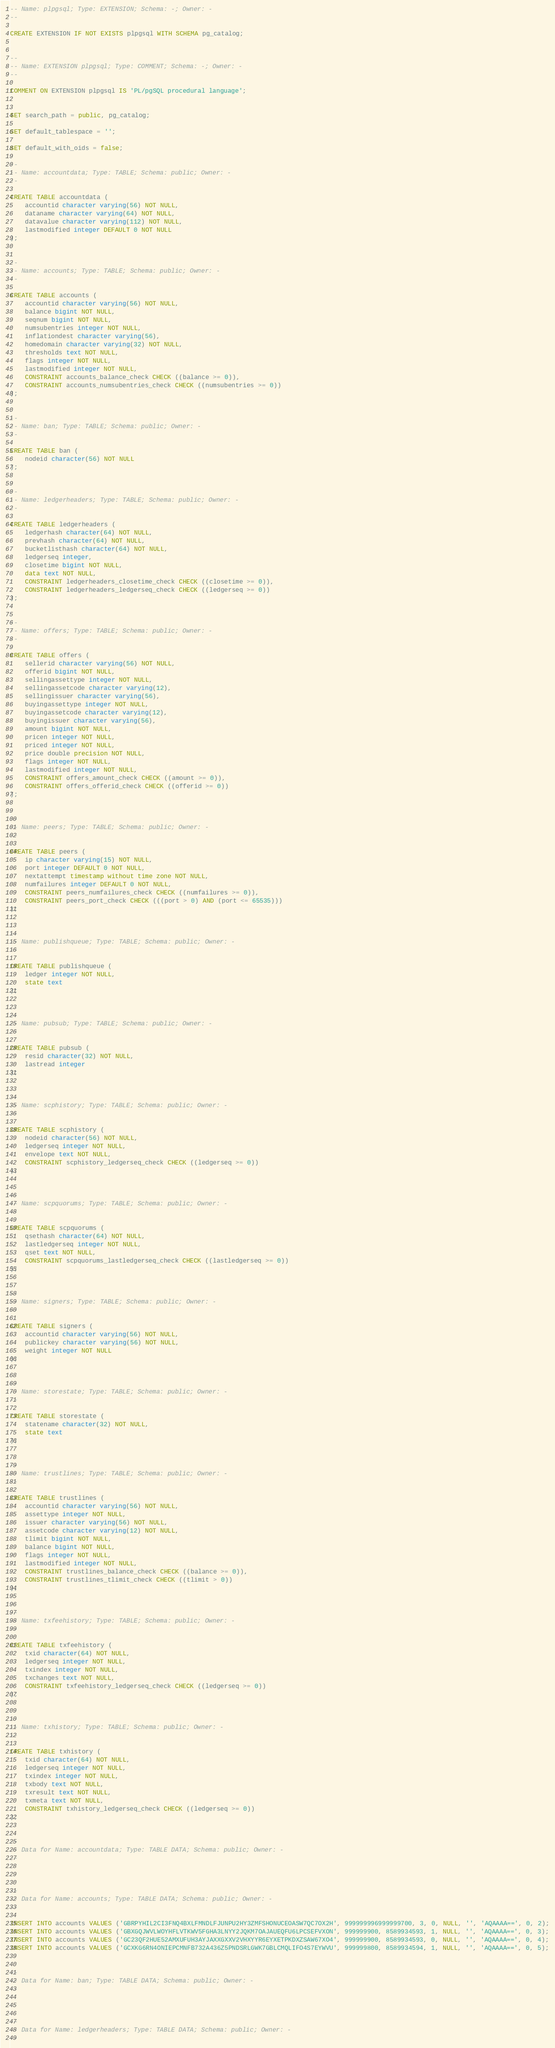Convert code to text. <code><loc_0><loc_0><loc_500><loc_500><_SQL_>-- Name: plpgsql; Type: EXTENSION; Schema: -; Owner: -
--

CREATE EXTENSION IF NOT EXISTS plpgsql WITH SCHEMA pg_catalog;


--
-- Name: EXTENSION plpgsql; Type: COMMENT; Schema: -; Owner: -
--

COMMENT ON EXTENSION plpgsql IS 'PL/pgSQL procedural language';


SET search_path = public, pg_catalog;

SET default_tablespace = '';

SET default_with_oids = false;

--
-- Name: accountdata; Type: TABLE; Schema: public; Owner: -
--

CREATE TABLE accountdata (
    accountid character varying(56) NOT NULL,
    dataname character varying(64) NOT NULL,
    datavalue character varying(112) NOT NULL,
    lastmodified integer DEFAULT 0 NOT NULL
);


--
-- Name: accounts; Type: TABLE; Schema: public; Owner: -
--

CREATE TABLE accounts (
    accountid character varying(56) NOT NULL,
    balance bigint NOT NULL,
    seqnum bigint NOT NULL,
    numsubentries integer NOT NULL,
    inflationdest character varying(56),
    homedomain character varying(32) NOT NULL,
    thresholds text NOT NULL,
    flags integer NOT NULL,
    lastmodified integer NOT NULL,
    CONSTRAINT accounts_balance_check CHECK ((balance >= 0)),
    CONSTRAINT accounts_numsubentries_check CHECK ((numsubentries >= 0))
);


--
-- Name: ban; Type: TABLE; Schema: public; Owner: -
--

CREATE TABLE ban (
    nodeid character(56) NOT NULL
);


--
-- Name: ledgerheaders; Type: TABLE; Schema: public; Owner: -
--

CREATE TABLE ledgerheaders (
    ledgerhash character(64) NOT NULL,
    prevhash character(64) NOT NULL,
    bucketlisthash character(64) NOT NULL,
    ledgerseq integer,
    closetime bigint NOT NULL,
    data text NOT NULL,
    CONSTRAINT ledgerheaders_closetime_check CHECK ((closetime >= 0)),
    CONSTRAINT ledgerheaders_ledgerseq_check CHECK ((ledgerseq >= 0))
);


--
-- Name: offers; Type: TABLE; Schema: public; Owner: -
--

CREATE TABLE offers (
    sellerid character varying(56) NOT NULL,
    offerid bigint NOT NULL,
    sellingassettype integer NOT NULL,
    sellingassetcode character varying(12),
    sellingissuer character varying(56),
    buyingassettype integer NOT NULL,
    buyingassetcode character varying(12),
    buyingissuer character varying(56),
    amount bigint NOT NULL,
    pricen integer NOT NULL,
    priced integer NOT NULL,
    price double precision NOT NULL,
    flags integer NOT NULL,
    lastmodified integer NOT NULL,
    CONSTRAINT offers_amount_check CHECK ((amount >= 0)),
    CONSTRAINT offers_offerid_check CHECK ((offerid >= 0))
);


--
-- Name: peers; Type: TABLE; Schema: public; Owner: -
--

CREATE TABLE peers (
    ip character varying(15) NOT NULL,
    port integer DEFAULT 0 NOT NULL,
    nextattempt timestamp without time zone NOT NULL,
    numfailures integer DEFAULT 0 NOT NULL,
    CONSTRAINT peers_numfailures_check CHECK ((numfailures >= 0)),
    CONSTRAINT peers_port_check CHECK (((port > 0) AND (port <= 65535)))
);


--
-- Name: publishqueue; Type: TABLE; Schema: public; Owner: -
--

CREATE TABLE publishqueue (
    ledger integer NOT NULL,
    state text
);


--
-- Name: pubsub; Type: TABLE; Schema: public; Owner: -
--

CREATE TABLE pubsub (
    resid character(32) NOT NULL,
    lastread integer
);


--
-- Name: scphistory; Type: TABLE; Schema: public; Owner: -
--

CREATE TABLE scphistory (
    nodeid character(56) NOT NULL,
    ledgerseq integer NOT NULL,
    envelope text NOT NULL,
    CONSTRAINT scphistory_ledgerseq_check CHECK ((ledgerseq >= 0))
);


--
-- Name: scpquorums; Type: TABLE; Schema: public; Owner: -
--

CREATE TABLE scpquorums (
    qsethash character(64) NOT NULL,
    lastledgerseq integer NOT NULL,
    qset text NOT NULL,
    CONSTRAINT scpquorums_lastledgerseq_check CHECK ((lastledgerseq >= 0))
);


--
-- Name: signers; Type: TABLE; Schema: public; Owner: -
--

CREATE TABLE signers (
    accountid character varying(56) NOT NULL,
    publickey character varying(56) NOT NULL,
    weight integer NOT NULL
);


--
-- Name: storestate; Type: TABLE; Schema: public; Owner: -
--

CREATE TABLE storestate (
    statename character(32) NOT NULL,
    state text
);


--
-- Name: trustlines; Type: TABLE; Schema: public; Owner: -
--

CREATE TABLE trustlines (
    accountid character varying(56) NOT NULL,
    assettype integer NOT NULL,
    issuer character varying(56) NOT NULL,
    assetcode character varying(12) NOT NULL,
    tlimit bigint NOT NULL,
    balance bigint NOT NULL,
    flags integer NOT NULL,
    lastmodified integer NOT NULL,
    CONSTRAINT trustlines_balance_check CHECK ((balance >= 0)),
    CONSTRAINT trustlines_tlimit_check CHECK ((tlimit > 0))
);


--
-- Name: txfeehistory; Type: TABLE; Schema: public; Owner: -
--

CREATE TABLE txfeehistory (
    txid character(64) NOT NULL,
    ledgerseq integer NOT NULL,
    txindex integer NOT NULL,
    txchanges text NOT NULL,
    CONSTRAINT txfeehistory_ledgerseq_check CHECK ((ledgerseq >= 0))
);


--
-- Name: txhistory; Type: TABLE; Schema: public; Owner: -
--

CREATE TABLE txhistory (
    txid character(64) NOT NULL,
    ledgerseq integer NOT NULL,
    txindex integer NOT NULL,
    txbody text NOT NULL,
    txresult text NOT NULL,
    txmeta text NOT NULL,
    CONSTRAINT txhistory_ledgerseq_check CHECK ((ledgerseq >= 0))
);


--
-- Data for Name: accountdata; Type: TABLE DATA; Schema: public; Owner: -
--



--
-- Data for Name: accounts; Type: TABLE DATA; Schema: public; Owner: -
--

INSERT INTO accounts VALUES ('GBRPYHIL2CI3FNQ4BXLFMNDLFJUNPU2HY3ZMFSHONUCEOASW7QC7OX2H', 999999996999999700, 3, 0, NULL, '', 'AQAAAA==', 0, 2);
INSERT INTO accounts VALUES ('GBXGQJWVLWOYHFLVTKWV5FGHA3LNYY2JQKM7OAJAUEQFU6LPCSEFVXON', 999999900, 8589934593, 1, NULL, '', 'AQAAAA==', 0, 3);
INSERT INTO accounts VALUES ('GC23QF2HUE52AMXUFUH3AYJAXXGXXV2VHXYYR6EYXETPKDXZSAW67XO4', 999999900, 8589934593, 0, NULL, '', 'AQAAAA==', 0, 4);
INSERT INTO accounts VALUES ('GCXKG6RN4ONIEPCMNFB732A436Z5PNDSRLGWK7GBLCMQLIFO4S7EYWVU', 999999800, 8589934594, 1, NULL, '', 'AQAAAA==', 0, 5);


--
-- Data for Name: ban; Type: TABLE DATA; Schema: public; Owner: -
--



--
-- Data for Name: ledgerheaders; Type: TABLE DATA; Schema: public; Owner: -
--
</code> 